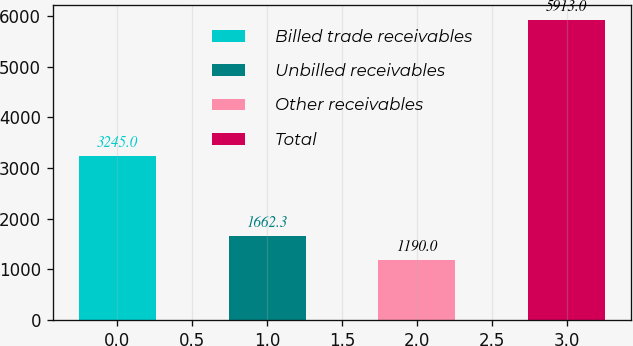Convert chart to OTSL. <chart><loc_0><loc_0><loc_500><loc_500><bar_chart><fcel>Billed trade receivables<fcel>Unbilled receivables<fcel>Other receivables<fcel>Total<nl><fcel>3245<fcel>1662.3<fcel>1190<fcel>5913<nl></chart> 